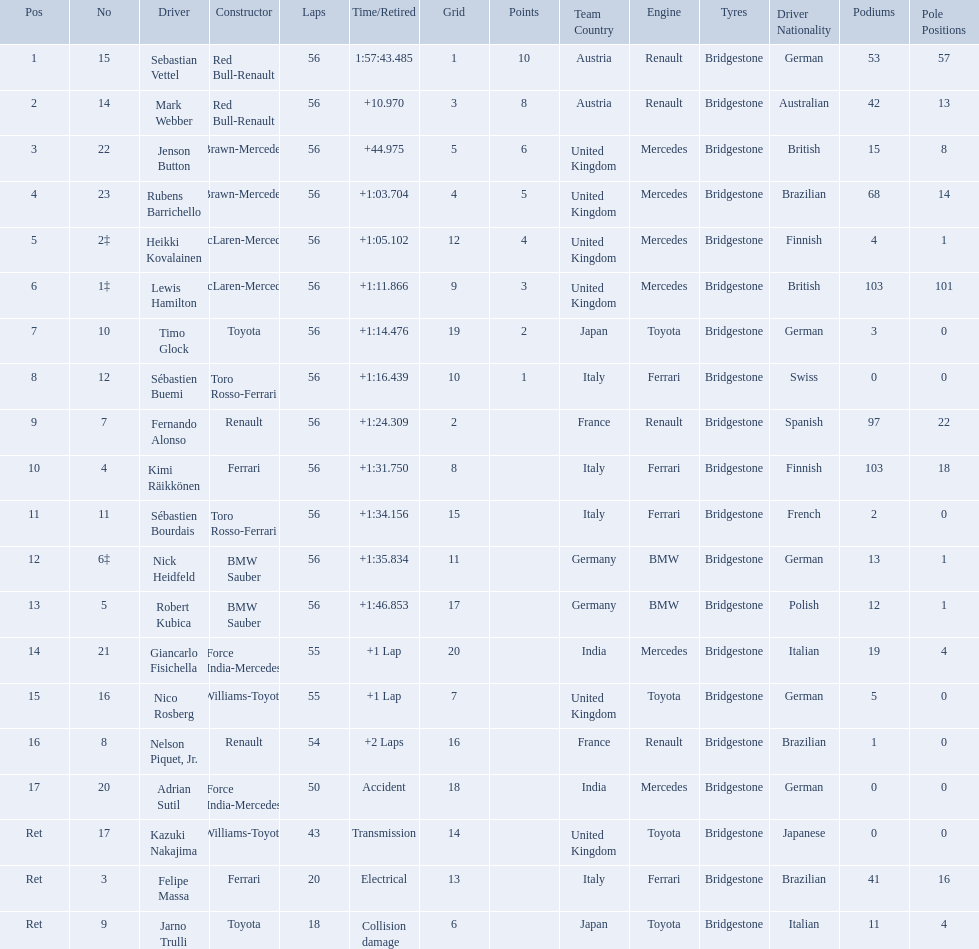Who were all the drivers? Sebastian Vettel, Mark Webber, Jenson Button, Rubens Barrichello, Heikki Kovalainen, Lewis Hamilton, Timo Glock, Sébastien Buemi, Fernando Alonso, Kimi Räikkönen, Sébastien Bourdais, Nick Heidfeld, Robert Kubica, Giancarlo Fisichella, Nico Rosberg, Nelson Piquet, Jr., Adrian Sutil, Kazuki Nakajima, Felipe Massa, Jarno Trulli. Which of these didn't have ferrari as a constructor? Sebastian Vettel, Mark Webber, Jenson Button, Rubens Barrichello, Heikki Kovalainen, Lewis Hamilton, Timo Glock, Sébastien Buemi, Fernando Alonso, Sébastien Bourdais, Nick Heidfeld, Robert Kubica, Giancarlo Fisichella, Nico Rosberg, Nelson Piquet, Jr., Adrian Sutil, Kazuki Nakajima, Jarno Trulli. Which of these was in first place? Sebastian Vettel. Who were all of the drivers in the 2009 chinese grand prix? Sebastian Vettel, Mark Webber, Jenson Button, Rubens Barrichello, Heikki Kovalainen, Lewis Hamilton, Timo Glock, Sébastien Buemi, Fernando Alonso, Kimi Räikkönen, Sébastien Bourdais, Nick Heidfeld, Robert Kubica, Giancarlo Fisichella, Nico Rosberg, Nelson Piquet, Jr., Adrian Sutil, Kazuki Nakajima, Felipe Massa, Jarno Trulli. And what were their finishing times? 1:57:43.485, +10.970, +44.975, +1:03.704, +1:05.102, +1:11.866, +1:14.476, +1:16.439, +1:24.309, +1:31.750, +1:34.156, +1:35.834, +1:46.853, +1 Lap, +1 Lap, +2 Laps, Accident, Transmission, Electrical, Collision damage. Which player faced collision damage and retired from the race? Jarno Trulli. Why did the  toyota retire Collision damage. What was the drivers name? Jarno Trulli. 